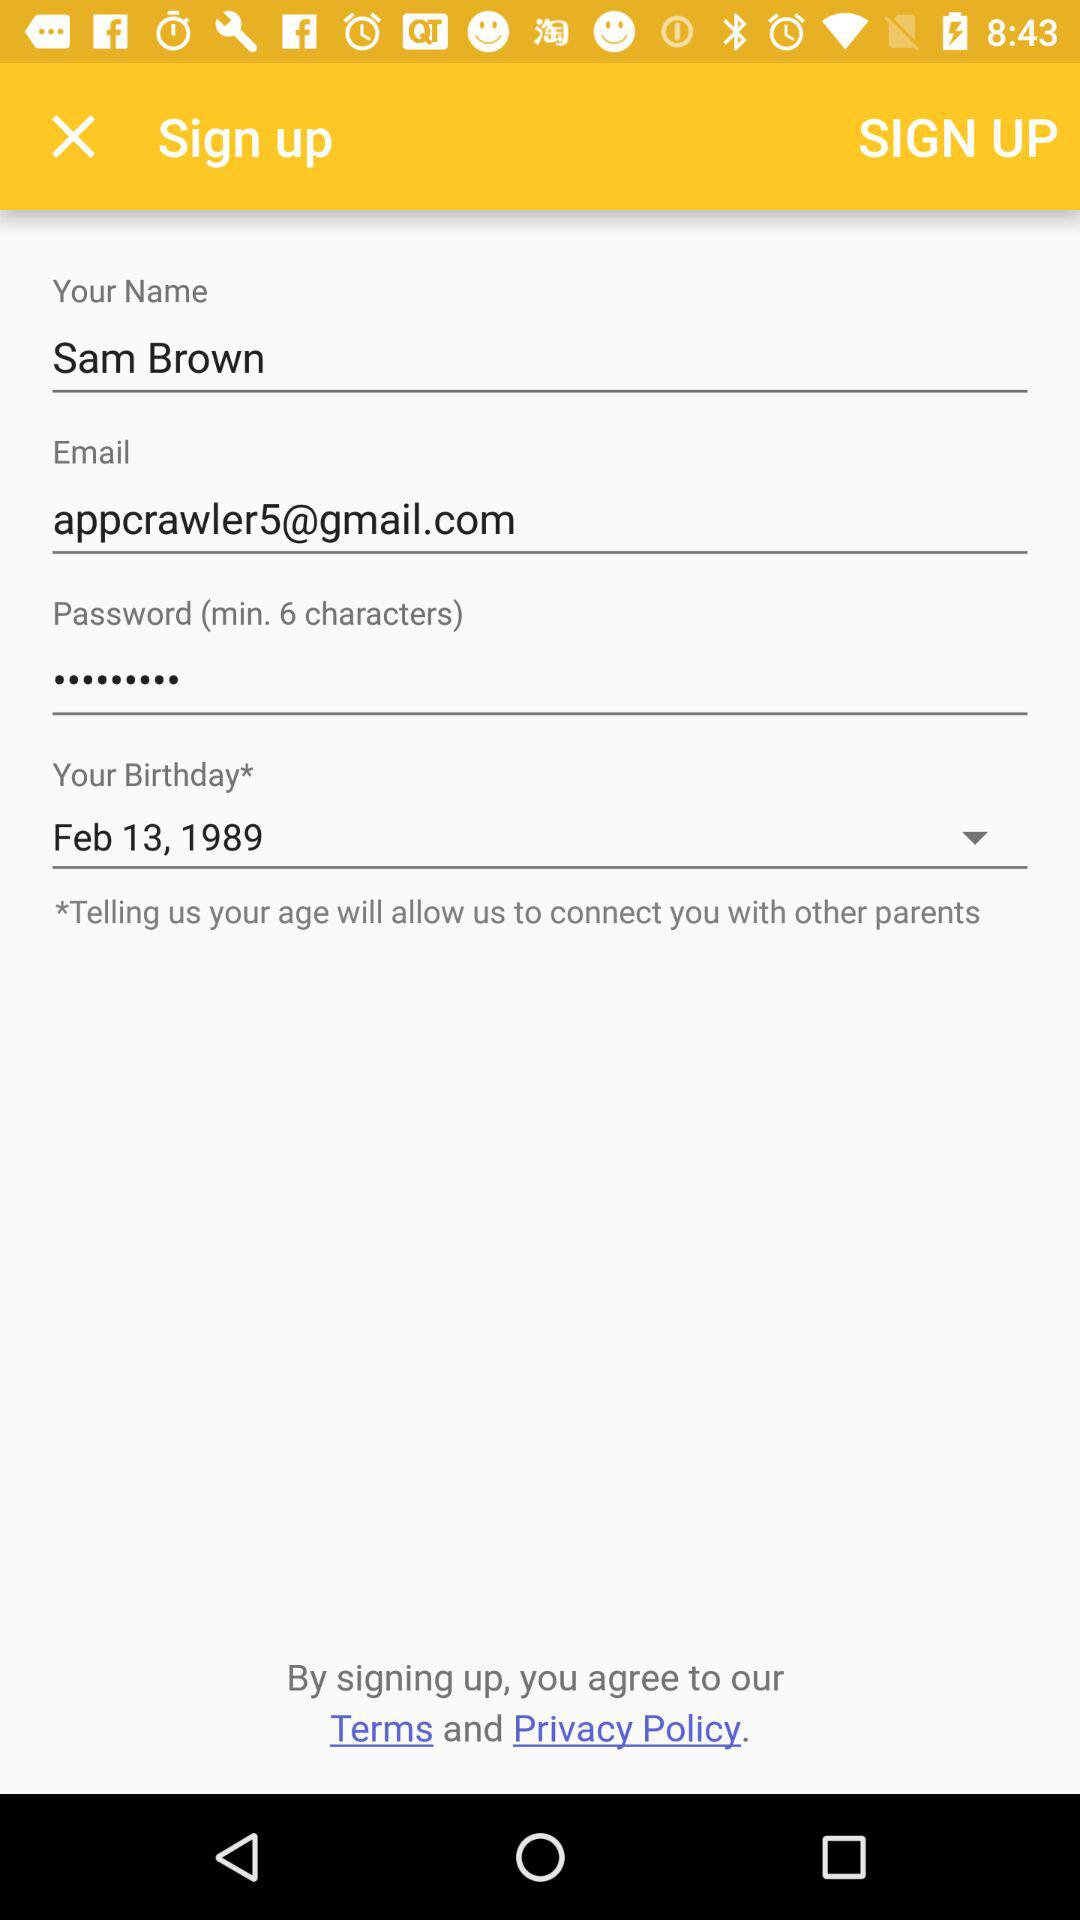What is the name? The name is Sam Brown. 